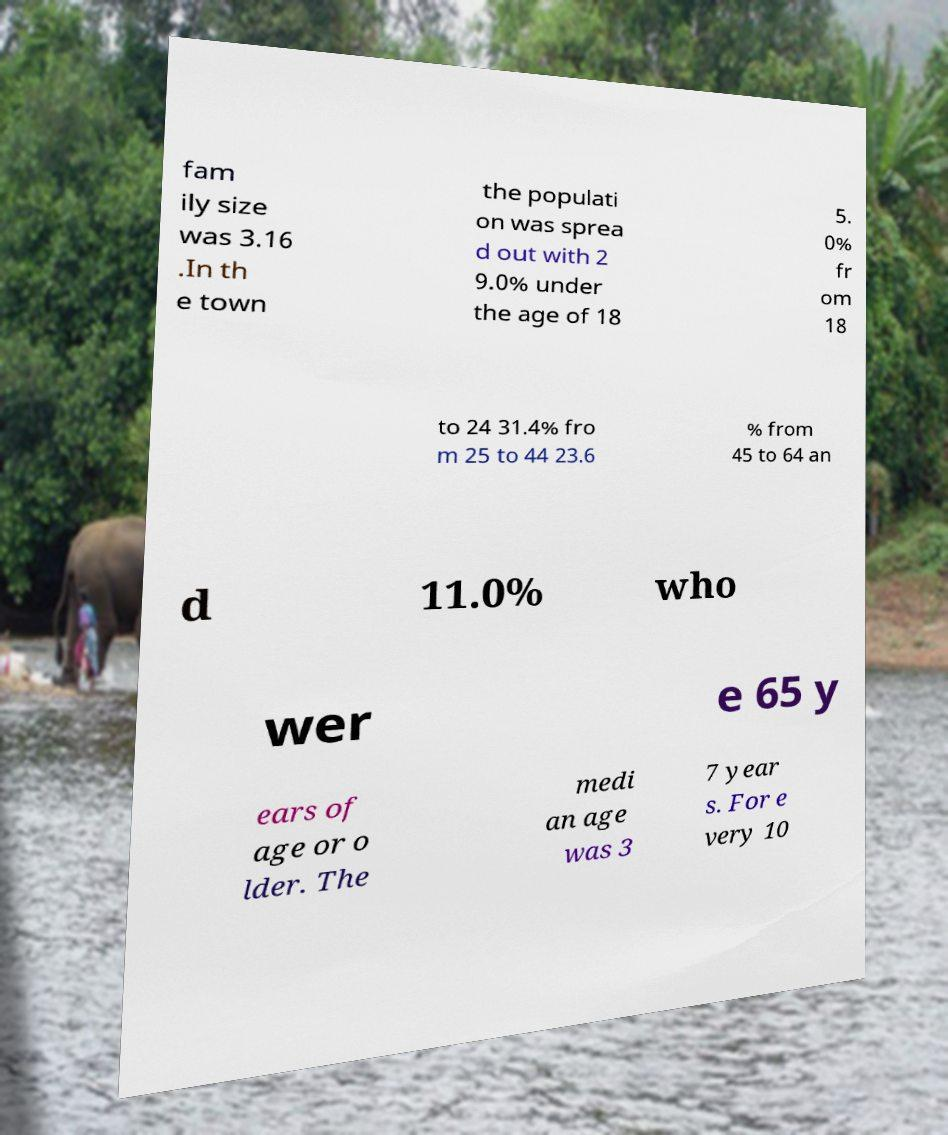Please read and relay the text visible in this image. What does it say? fam ily size was 3.16 .In th e town the populati on was sprea d out with 2 9.0% under the age of 18 5. 0% fr om 18 to 24 31.4% fro m 25 to 44 23.6 % from 45 to 64 an d 11.0% who wer e 65 y ears of age or o lder. The medi an age was 3 7 year s. For e very 10 